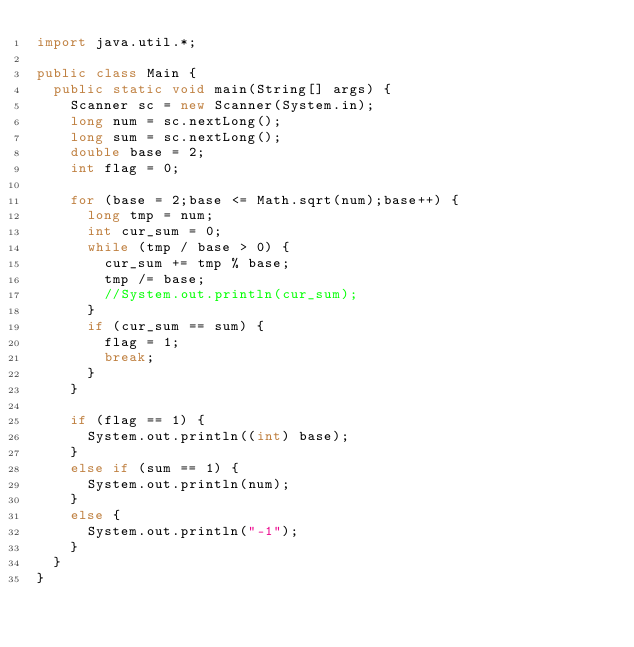Convert code to text. <code><loc_0><loc_0><loc_500><loc_500><_Java_>import java.util.*;

public class Main {
	public static void main(String[] args) {
		Scanner sc = new Scanner(System.in);
		long num = sc.nextLong();
		long sum = sc.nextLong();
		double base = 2;
		int flag = 0;

		for (base = 2;base <= Math.sqrt(num);base++) {
			long tmp = num;
			int cur_sum = 0;
			while (tmp / base > 0) {
				cur_sum += tmp % base;
				tmp /= base;
				//System.out.println(cur_sum);
			}
			if (cur_sum == sum) {
				flag = 1;
				break;
			}
		}
		
		if (flag == 1) {
			System.out.println((int) base);
		}
		else if (sum == 1) {
			System.out.println(num);
		}
		else {
			System.out.println("-1");
		}
	}
}</code> 